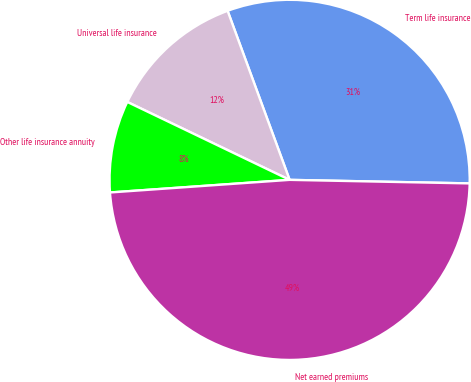<chart> <loc_0><loc_0><loc_500><loc_500><pie_chart><fcel>Term life insurance<fcel>Universal life insurance<fcel>Other life insurance annuity<fcel>Net earned premiums<nl><fcel>30.91%<fcel>12.28%<fcel>8.24%<fcel>48.57%<nl></chart> 